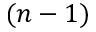Convert formula to latex. <formula><loc_0><loc_0><loc_500><loc_500>( n - 1 )</formula> 